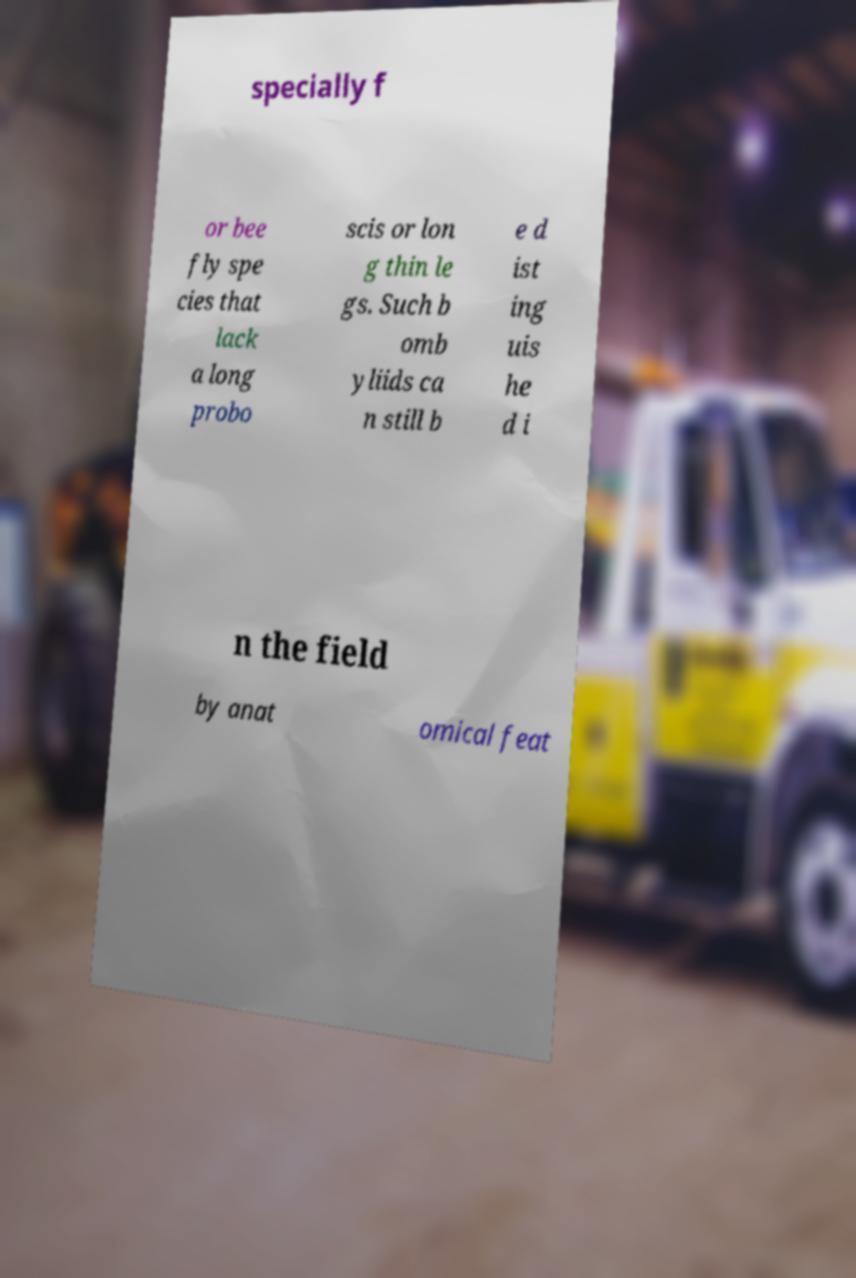Please identify and transcribe the text found in this image. specially f or bee fly spe cies that lack a long probo scis or lon g thin le gs. Such b omb yliids ca n still b e d ist ing uis he d i n the field by anat omical feat 